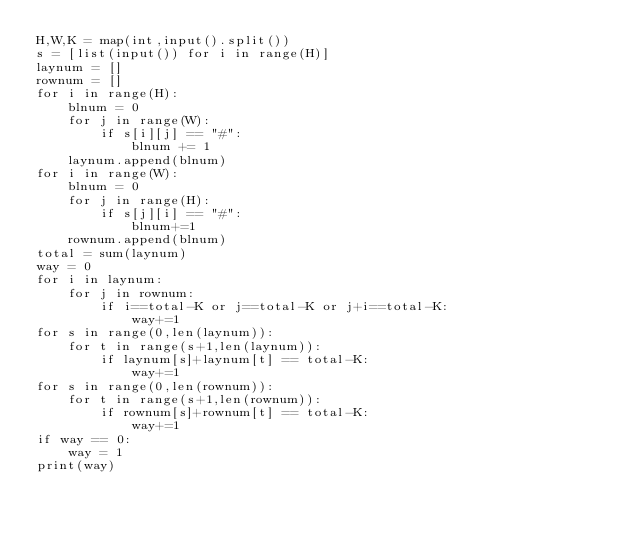Convert code to text. <code><loc_0><loc_0><loc_500><loc_500><_Python_>H,W,K = map(int,input().split())
s = [list(input()) for i in range(H)]
laynum = []
rownum = []
for i in range(H):
    blnum = 0
    for j in range(W):
        if s[i][j] == "#":
            blnum += 1
    laynum.append(blnum)
for i in range(W):
    blnum = 0
    for j in range(H):
        if s[j][i] == "#":
            blnum+=1
    rownum.append(blnum)
total = sum(laynum)
way = 0
for i in laynum:
    for j in rownum:
        if i==total-K or j==total-K or j+i==total-K:
            way+=1
for s in range(0,len(laynum)):
    for t in range(s+1,len(laynum)):
        if laynum[s]+laynum[t] == total-K:
            way+=1
for s in range(0,len(rownum)):
    for t in range(s+1,len(rownum)):
        if rownum[s]+rownum[t] == total-K:
            way+=1
if way == 0:
    way = 1
print(way)
</code> 